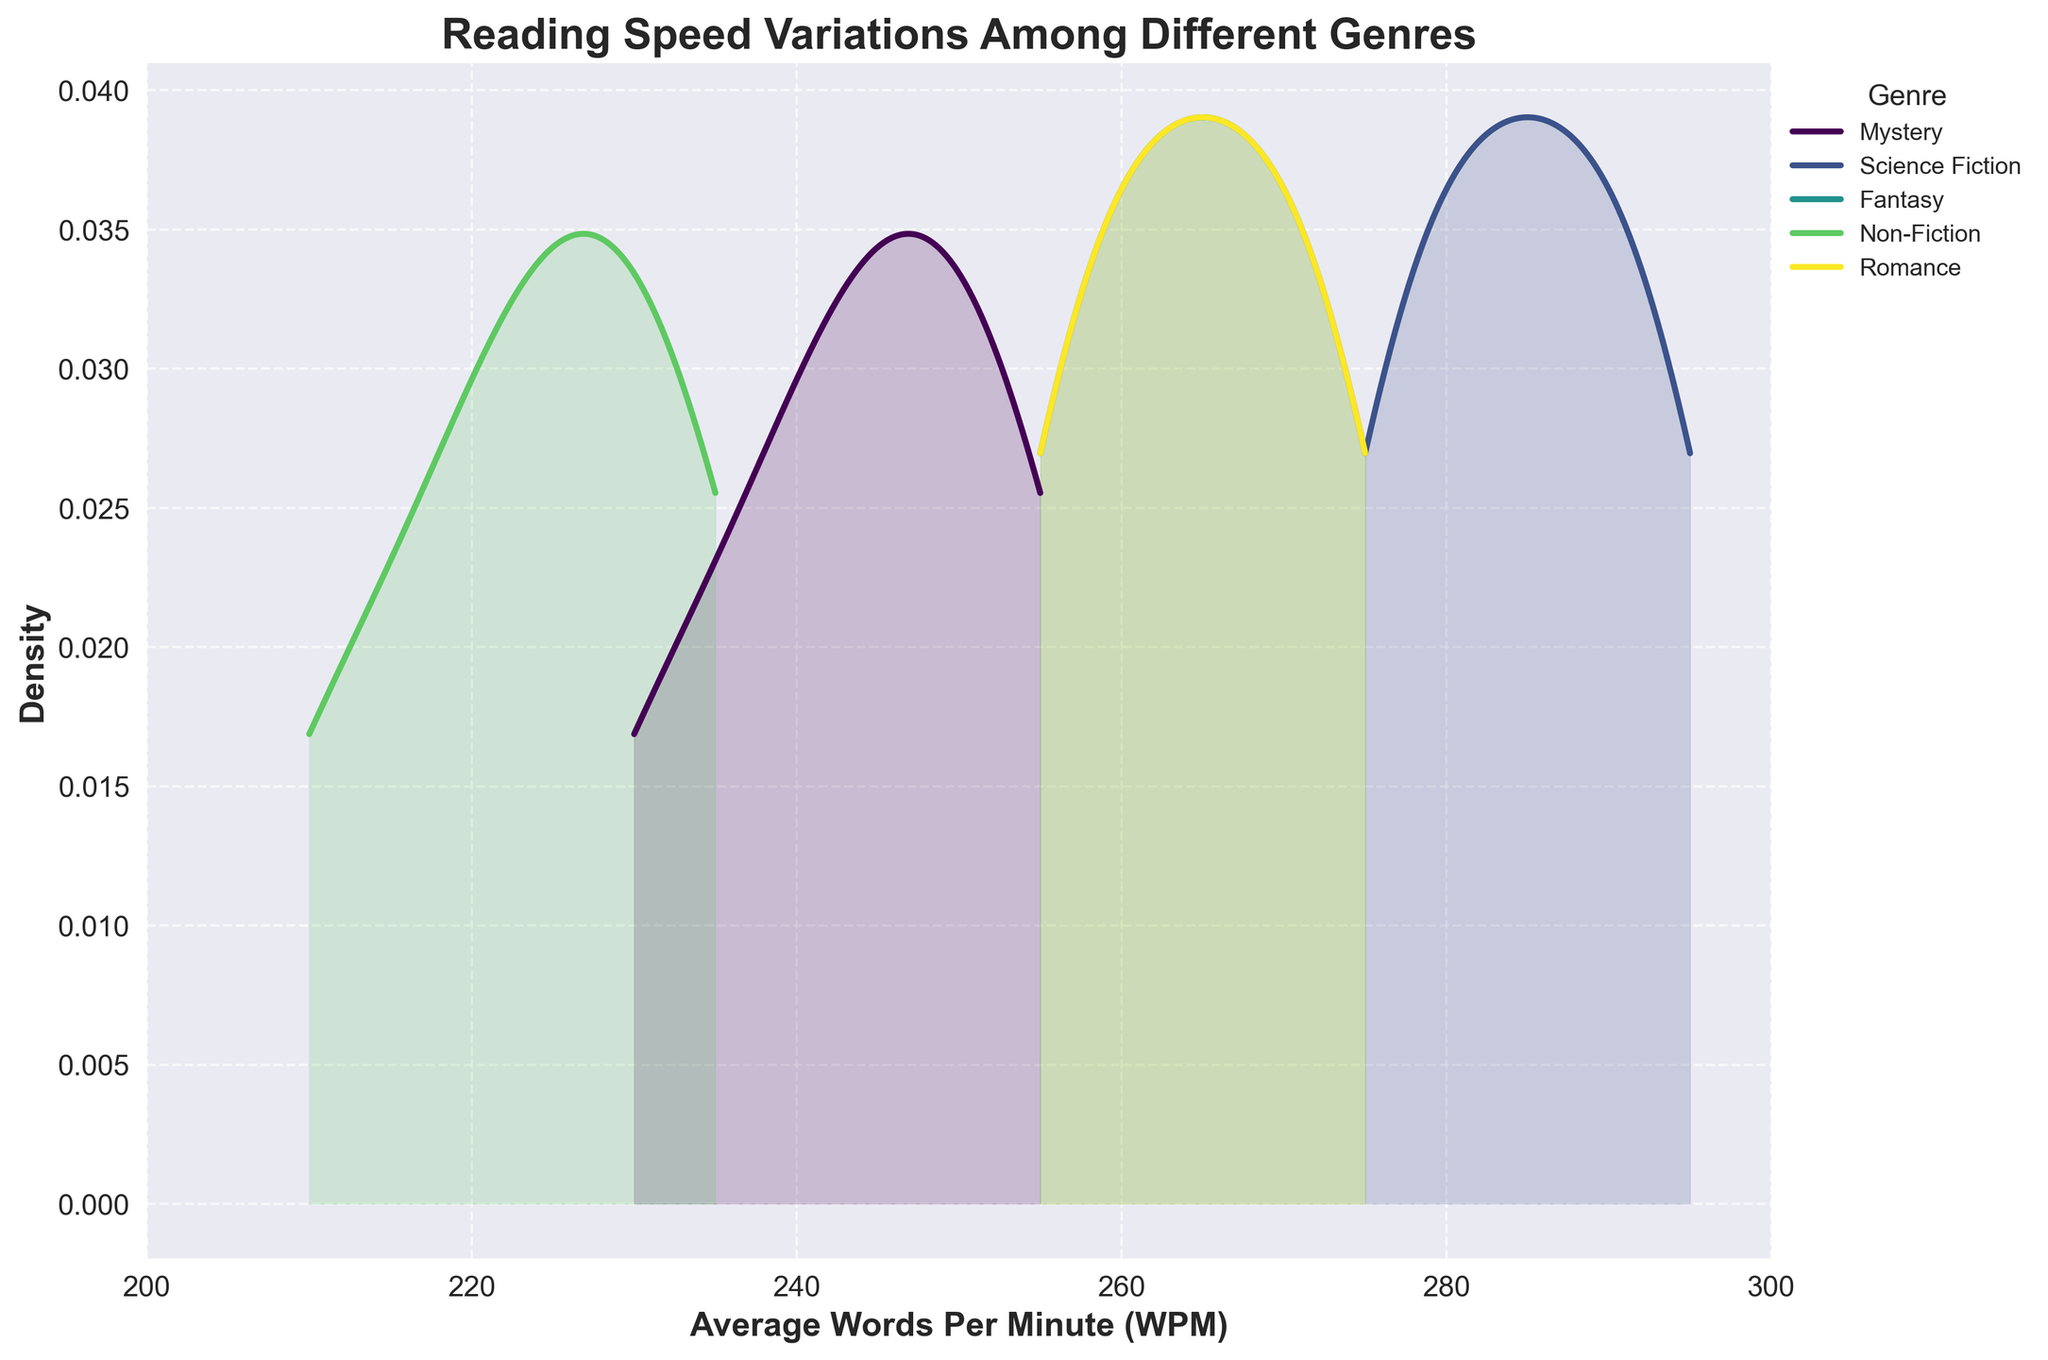What is the title of the figure? The title of the figure is displayed on top of the plot. It is usually in a bold and larger font size to distinguish it from other text.
Answer: Reading Speed Variations Among Different Genres What is the x-axis label on the plot? The x-axis label is typically found below the x-axis and provides a description of what the x-axis represents.
Answer: Average Words Per Minute (WPM) Which genre has the widest range of reading speeds? To determine the genre with the widest range, look at the spread of the density plot for each genre and assess which one covers the broadest range on the x-axis.
Answer: Science Fiction How does the density peak of Mystery compare to that of Non-Fiction? Compare the density peaks of the plots for Mystery and Non-Fiction. Look at the height of the peaks for both genres.
Answer: The density peak for Mystery is higher than Non-Fiction Which genre is most likely to have readers with reading speeds around 255 WPM? Find the genre whose density plot has a prominent peak around the 255 WPM mark on the x-axis.
Answer: Mystery What is the approximate peak density value for Science Fiction? Identify the peak of the density plot for Science Fiction and estimate its y-axis value.
Answer: Approximately 0.032 Which two genres show similar reading speed distributions? Compare the shapes and peaks of the density plots for different genres to identify which two have similar distributions.
Answer: Fantasy and Romance What is the primary difference in reading speed distributions between Fantasy and Non-Fiction? Examine the density plots for Fantasy and Non-Fiction to describe the main differences in their shape, spread, or peaks.
Answer: Fantasy has a higher peak and covers higher WPMs than Non-Fiction Do any genres exhibit bimodal distribution in reading speeds? Check each genre's density plot to see if there are two distinct peaks, indicating a bimodal distribution.
Answer: No Which genre has the least variation in reading speeds? Identify the genre with the narrowest density plot, indicating the least variation in reading speeds.
Answer: Non-Fiction 